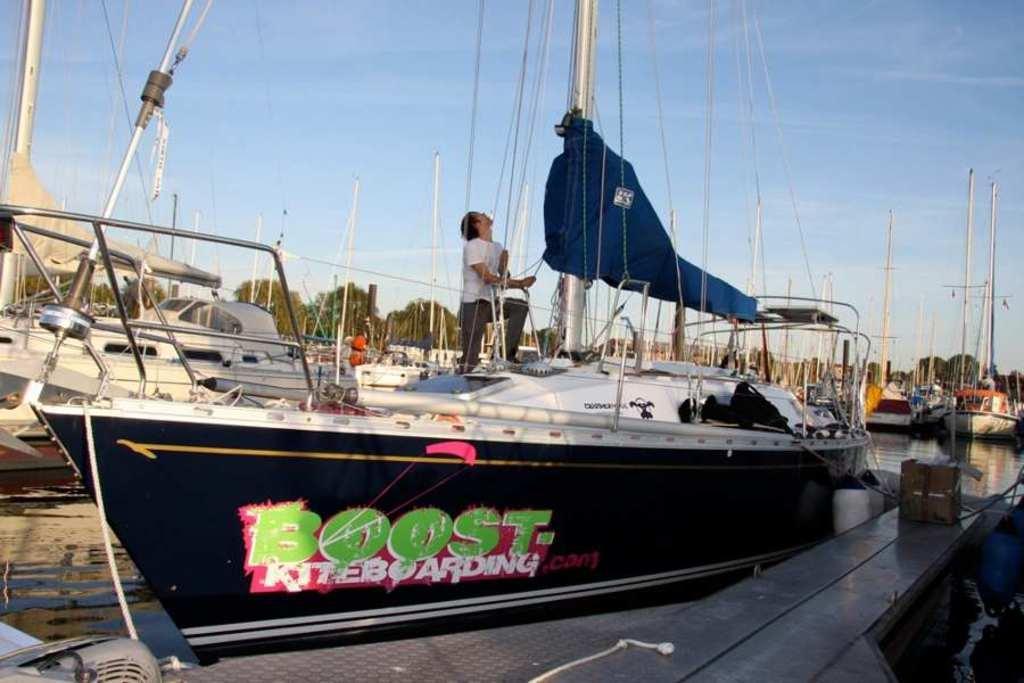Could you give a brief overview of what you see in this image? In this picture we can see some boats, there is water in the middle, we can see a man in the front, in the background there are some trees, we can see the sky at the top of the picture. 